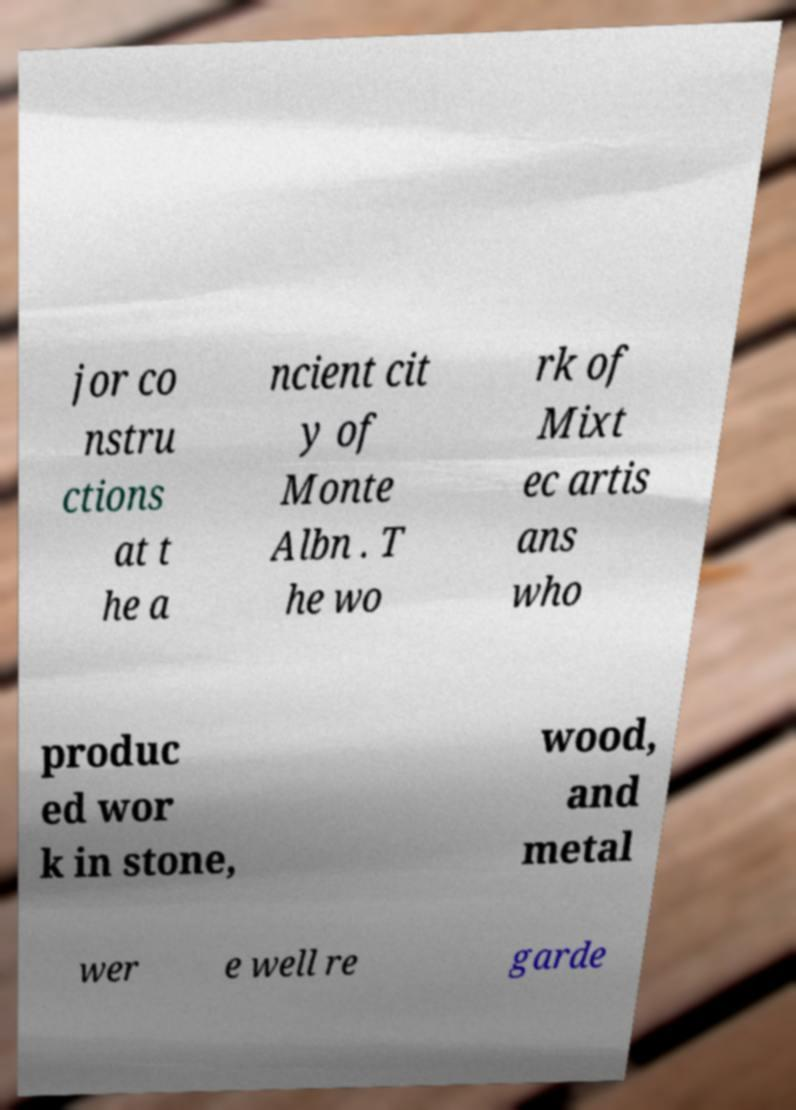I need the written content from this picture converted into text. Can you do that? jor co nstru ctions at t he a ncient cit y of Monte Albn . T he wo rk of Mixt ec artis ans who produc ed wor k in stone, wood, and metal wer e well re garde 